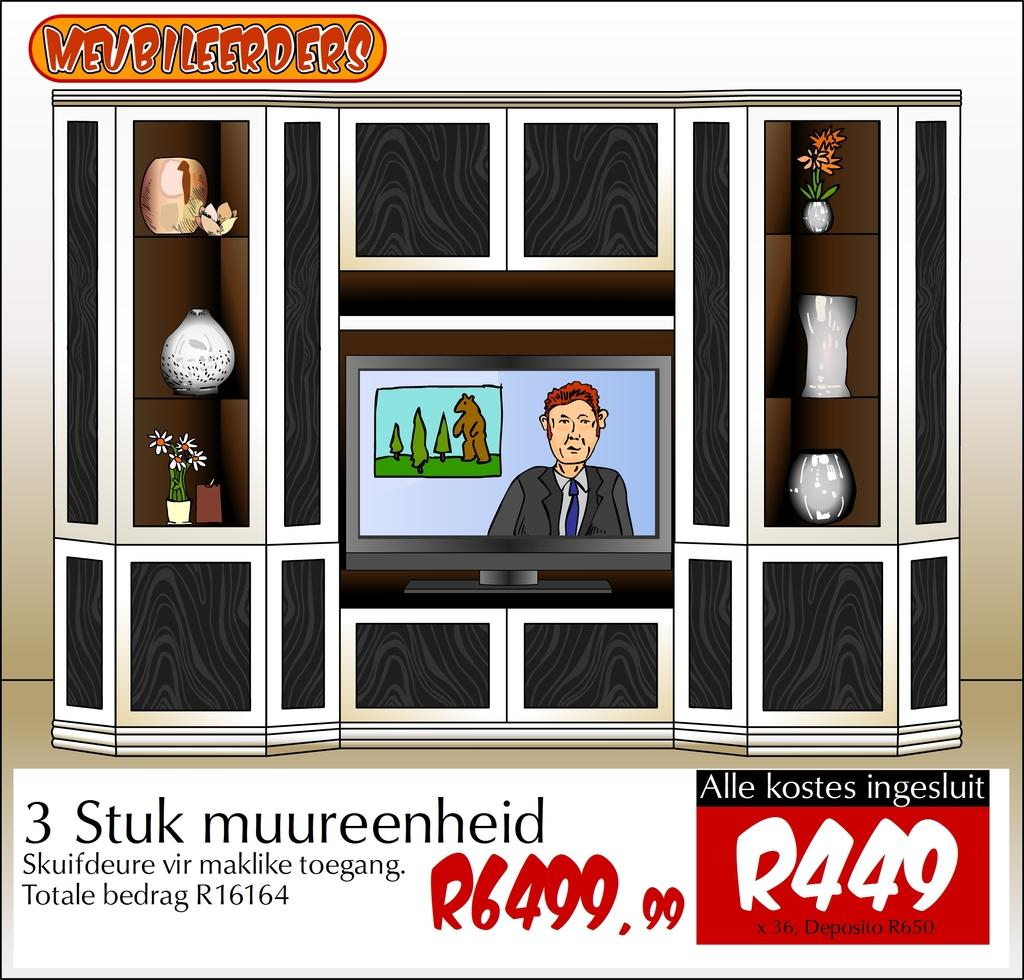What type of image is being described? The image is animated. What is the primary object in the image? There is a screen in the image. What type of furniture is present in the image? There are cupboards in the image. What can be found on the shelves in the image? There are shelves with objects in the image. Where is text located in the image? There is text at the top and bottom of the image. What type of paste is being used to stick the fan to the screen in the image? There is no fan present in the image, so there is no paste being used to stick it to the screen. 